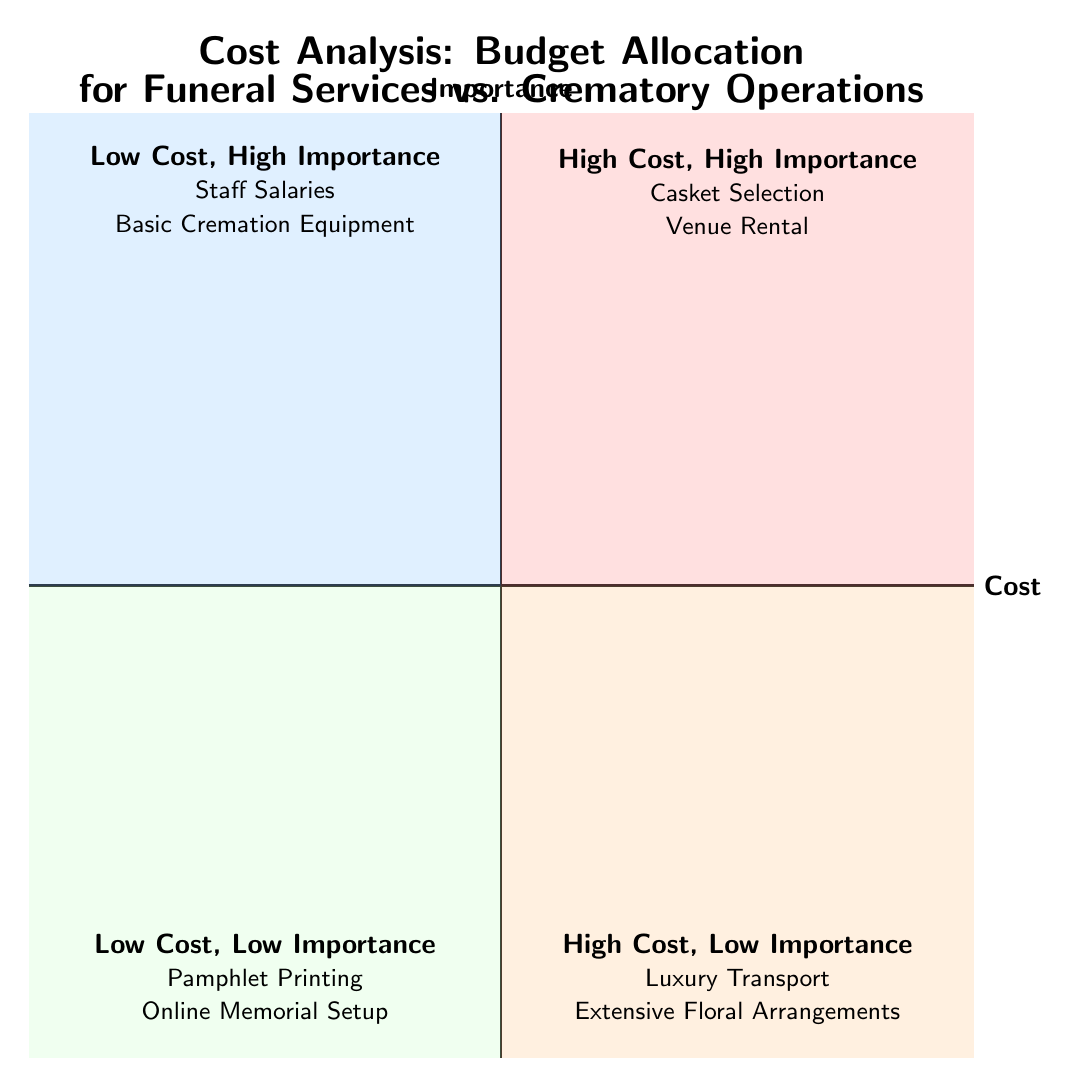What are the items in the High Cost, High Importance quadrant? The High Cost, High Importance quadrant contains two items listed: "Casket Selection" and "Venue Rental."
Answer: Casket Selection, Venue Rental How many items are in the Low Cost, Low Importance quadrant? The Low Cost, Low Importance quadrant has two items, which are "Pamphlet Printing" and "Online Memorial Setup."
Answer: 2 Which quadrant includes Staff Salaries? Staff Salaries is located in the Low Cost, High Importance quadrant, indicating that it is a crucial but less expensive item.
Answer: Low Cost, High Importance What is the distinguishing factor of items inQuadrant 2? The items in Quadrant 2, "Luxury Transport" and "Extensive Floral Arrangements," are categorized as high cost but low importance, indicating less significance compared to their expenses.
Answer: High Cost, Low Importance What type of items are in the Low Cost, High Importance quadrant? The Low Cost, High Importance quadrant includes essential services such as "Staff Salaries" and "Basic Cremation Equipment," which are necessary for operations but are less expensive.
Answer: Essential services Which quadrant has casket selection and how is it classified? Casket Selection falls in the High Cost, High Importance quadrant, meaning it is both expensive and critical for funeral services.
Answer: High Cost, High Importance What is the relationship between extensive floral arrangements and importance? Extensive floral arrangements are placed in the High Cost, Low Importance quadrant, showing they incur significant expenses without a corresponding level of importance.
Answer: Low Importance How many quadrants are labeled as High Cost? There are two quadrants categorized as High Cost: High Cost, High Importance and High Cost, Low Importance.
Answer: 2 What color represents the Low Cost, Low Importance quadrant? The color representing the Low Cost, Low Importance quadrant is light green, visually differentiating it from other quadrants.
Answer: Light green 